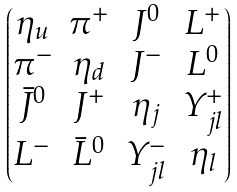Convert formula to latex. <formula><loc_0><loc_0><loc_500><loc_500>\begin{pmatrix} \eta _ { u } & \pi ^ { + } & J ^ { 0 } & L ^ { + } \\ \pi ^ { - } & \eta _ { d } & J ^ { - } & L ^ { 0 } \\ \bar { J } ^ { 0 } & J ^ { + } & \eta _ { j } & Y _ { j l } ^ { + } \\ L ^ { - } & \bar { L } ^ { 0 } & Y _ { j l } ^ { - } & \eta _ { l } \end{pmatrix}</formula> 